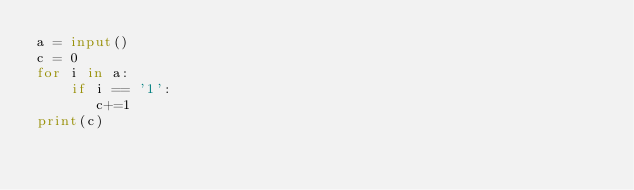<code> <loc_0><loc_0><loc_500><loc_500><_Python_>a = input()
c = 0
for i in a:
    if i == '1':
       c+=1
print(c)</code> 